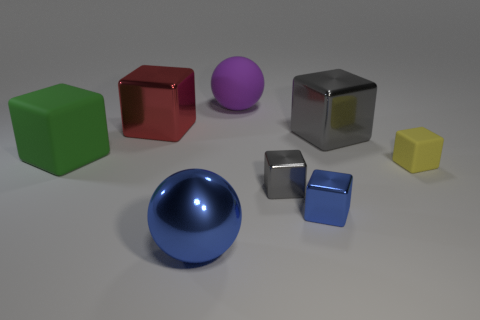Subtract all green blocks. How many blocks are left? 5 Subtract 1 blocks. How many blocks are left? 5 Subtract all blue blocks. How many blocks are left? 5 Subtract all brown blocks. Subtract all yellow balls. How many blocks are left? 6 Add 1 green rubber blocks. How many objects exist? 9 Subtract all blocks. How many objects are left? 2 Subtract all large gray metallic blocks. Subtract all purple rubber objects. How many objects are left? 6 Add 8 big red things. How many big red things are left? 9 Add 4 red metal things. How many red metal things exist? 5 Subtract 0 brown cubes. How many objects are left? 8 